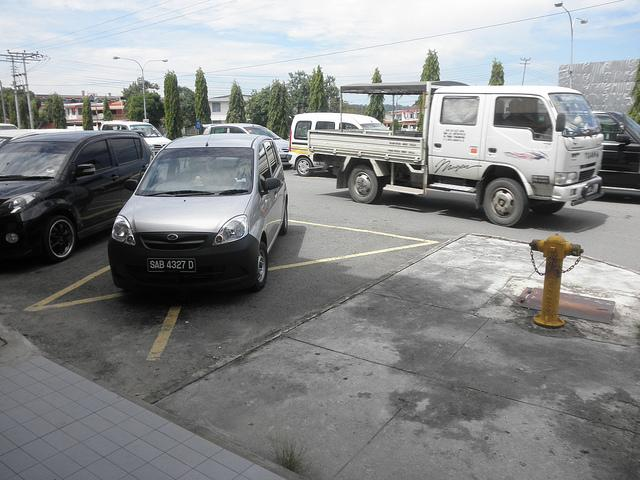Which car has violated the law?

Choices:
A) silver car
B) white car
C) grey car
D) black car silver car 